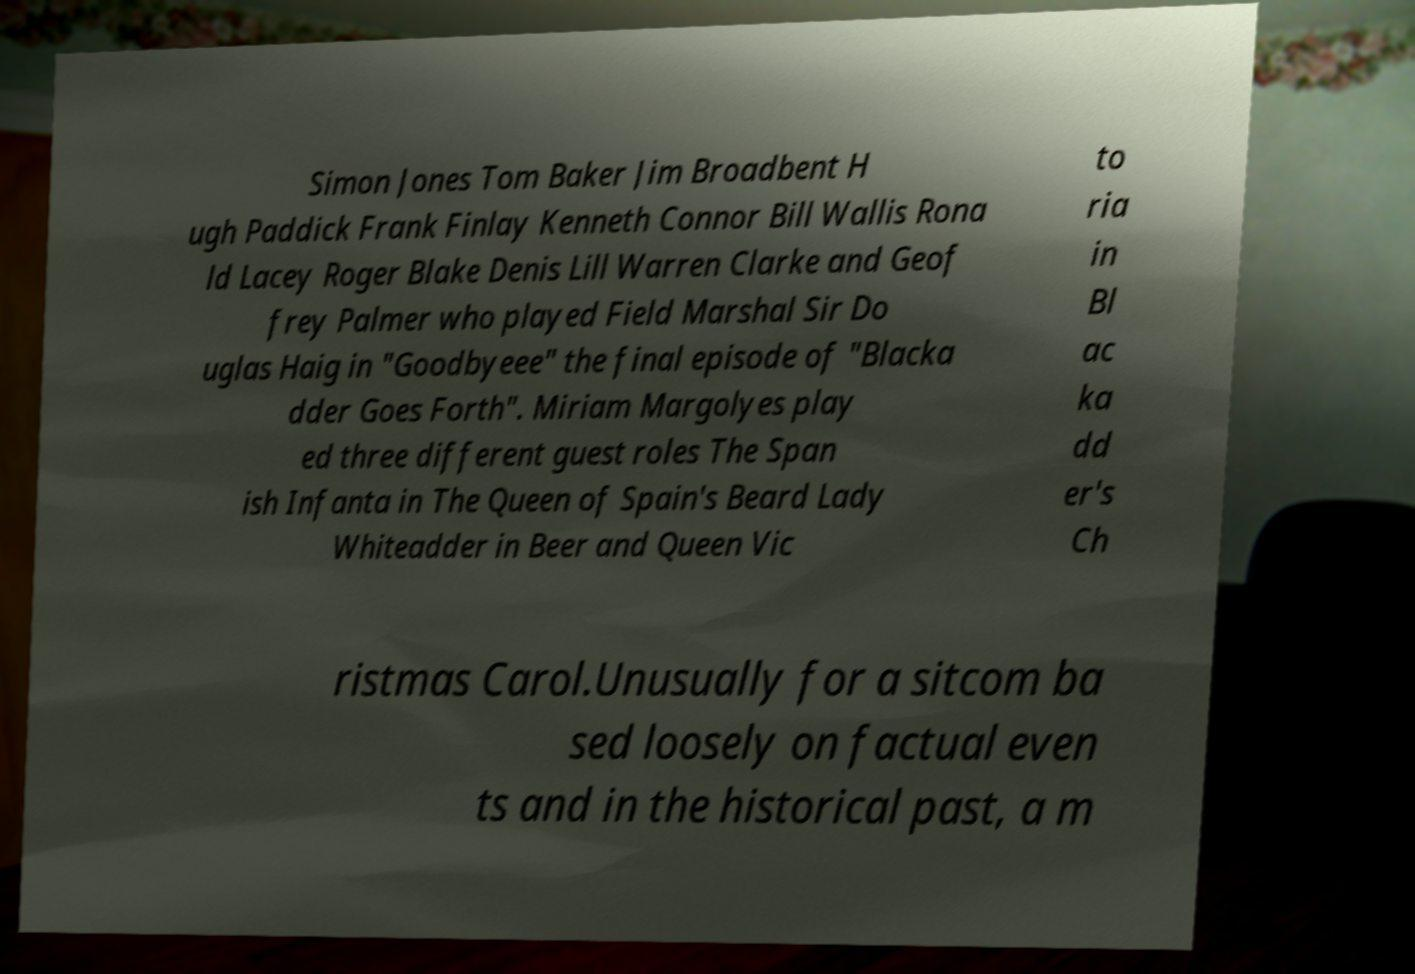I need the written content from this picture converted into text. Can you do that? Simon Jones Tom Baker Jim Broadbent H ugh Paddick Frank Finlay Kenneth Connor Bill Wallis Rona ld Lacey Roger Blake Denis Lill Warren Clarke and Geof frey Palmer who played Field Marshal Sir Do uglas Haig in "Goodbyeee" the final episode of "Blacka dder Goes Forth". Miriam Margolyes play ed three different guest roles The Span ish Infanta in The Queen of Spain's Beard Lady Whiteadder in Beer and Queen Vic to ria in Bl ac ka dd er's Ch ristmas Carol.Unusually for a sitcom ba sed loosely on factual even ts and in the historical past, a m 